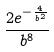Convert formula to latex. <formula><loc_0><loc_0><loc_500><loc_500>\frac { 2 e ^ { - \frac { 4 } { b ^ { 2 } } } } { b ^ { 8 } }</formula> 